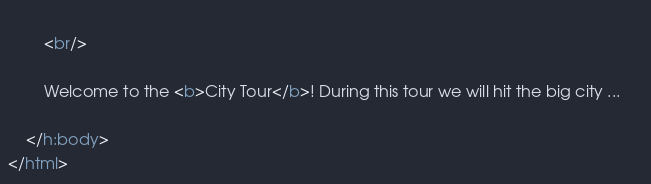<code> <loc_0><loc_0><loc_500><loc_500><_HTML_>		
		<br/>
	
		Welcome to the <b>City Tour</b>! During this tour we will hit the big city ...		
		
    </h:body>
</html>
</code> 